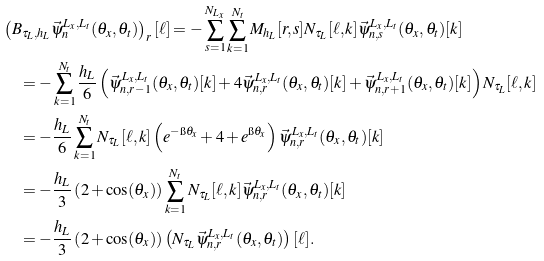<formula> <loc_0><loc_0><loc_500><loc_500>& \left ( B _ { \tau _ { L } , h _ { L } } \vec { \psi } _ { n } ^ { L _ { x } , L _ { t } } ( \theta _ { x } , \theta _ { t } ) \right ) _ { r } [ \ell ] = - \sum _ { s = 1 } ^ { N _ { L _ { x } } } \sum _ { k = 1 } ^ { N _ { t } } M _ { h _ { L } } [ r , s ] N _ { \tau _ { L } } [ \ell , k ] \vec { \psi } _ { n , s } ^ { L _ { x } , L _ { t } } ( \theta _ { x } , \theta _ { t } ) [ k ] \\ & \quad = - \sum _ { k = 1 } ^ { N _ { t } } \frac { h _ { L } } { 6 } \left ( \vec { \psi } _ { n , r - 1 } ^ { L _ { x } , L _ { t } } ( \theta _ { x } , \theta _ { t } ) [ k ] + 4 \vec { \psi } _ { n , r } ^ { L _ { x } , L _ { t } } ( \theta _ { x } , \theta _ { t } ) [ k ] + \vec { \psi } _ { n , r + 1 } ^ { L _ { x } , L _ { t } } ( \theta _ { x } , \theta _ { t } ) [ k ] \right ) N _ { \tau _ { L } } [ \ell , k ] \\ & \quad = - \frac { h _ { L } } { 6 } \sum _ { k = 1 } ^ { N _ { t } } N _ { \tau _ { L } } [ \ell , k ] \left ( e ^ { - \i \theta _ { x } } + 4 + e ^ { \i \theta _ { x } } \right ) \vec { \psi } _ { n , r } ^ { L _ { x } , L _ { t } } ( \theta _ { x } , \theta _ { t } ) [ k ] \\ & \quad = - \frac { h _ { L } } { 3 } \left ( 2 + \cos ( \theta _ { x } ) \right ) \sum _ { k = 1 } ^ { N _ { t } } N _ { \tau _ { L } } [ \ell , k ] \vec { \psi } _ { n , r } ^ { L _ { x } , L _ { t } } ( \theta _ { x } , \theta _ { t } ) [ k ] \\ & \quad = - \frac { h _ { L } } { 3 } \left ( 2 + \cos ( \theta _ { x } ) \right ) \left ( N _ { \tau _ { L } } \vec { \psi } _ { n , r } ^ { L _ { x } , L _ { t } } ( \theta _ { x } , \theta _ { t } ) \right ) [ \ell ] .</formula> 